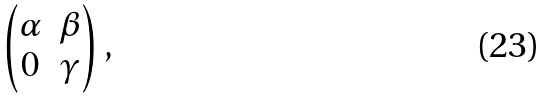Convert formula to latex. <formula><loc_0><loc_0><loc_500><loc_500>\begin{pmatrix} \alpha & \beta \\ 0 & \gamma \end{pmatrix} ,</formula> 